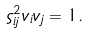<formula> <loc_0><loc_0><loc_500><loc_500>\varsigma _ { i j } ^ { 2 } v _ { i } v _ { j } = 1 .</formula> 